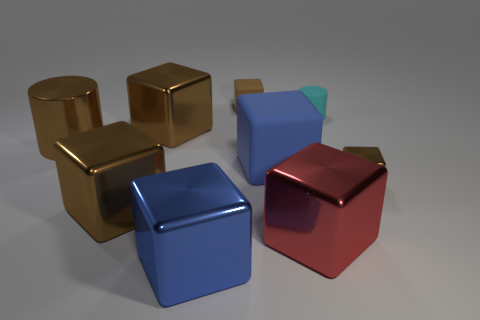How many brown cubes must be subtracted to get 2 brown cubes? 2 Subtract all red cylinders. How many brown blocks are left? 4 Subtract all red cubes. How many cubes are left? 6 Subtract all small brown blocks. How many blocks are left? 5 Subtract 1 cubes. How many cubes are left? 6 Subtract all green blocks. Subtract all blue spheres. How many blocks are left? 7 Add 1 brown metallic cylinders. How many objects exist? 10 Subtract all blocks. How many objects are left? 2 Subtract all tiny purple metal things. Subtract all red cubes. How many objects are left? 8 Add 6 brown cubes. How many brown cubes are left? 10 